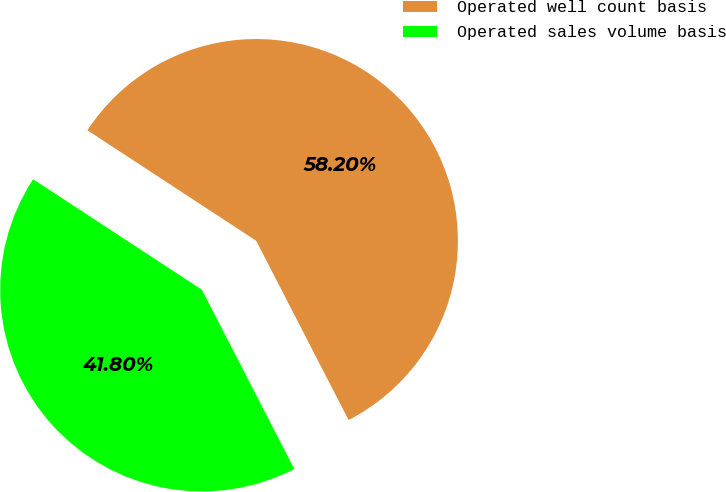Convert chart. <chart><loc_0><loc_0><loc_500><loc_500><pie_chart><fcel>Operated well count basis<fcel>Operated sales volume basis<nl><fcel>58.2%<fcel>41.8%<nl></chart> 